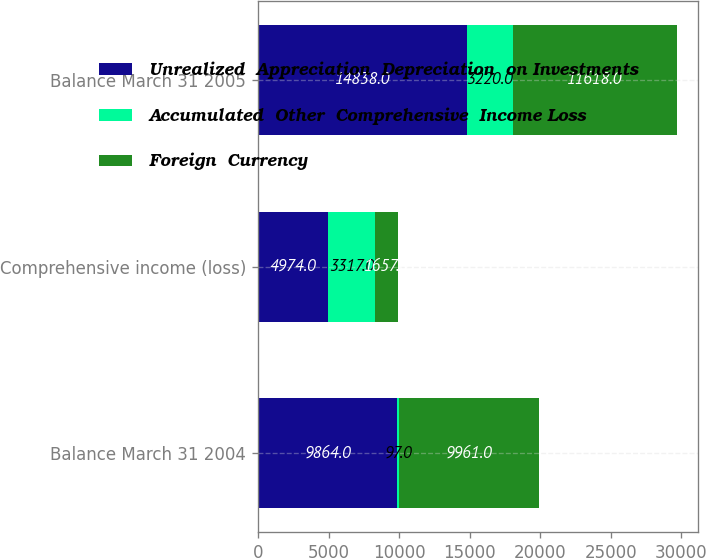<chart> <loc_0><loc_0><loc_500><loc_500><stacked_bar_chart><ecel><fcel>Balance March 31 2004<fcel>Comprehensive income (loss)<fcel>Balance March 31 2005<nl><fcel>Unrealized  Appreciation  Depreciation  on Investments<fcel>9864<fcel>4974<fcel>14838<nl><fcel>Accumulated  Other  Comprehensive  Income Loss<fcel>97<fcel>3317<fcel>3220<nl><fcel>Foreign  Currency<fcel>9961<fcel>1657<fcel>11618<nl></chart> 